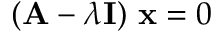Convert formula to latex. <formula><loc_0><loc_0><loc_500><loc_500>( A - \lambda I ) x = 0</formula> 